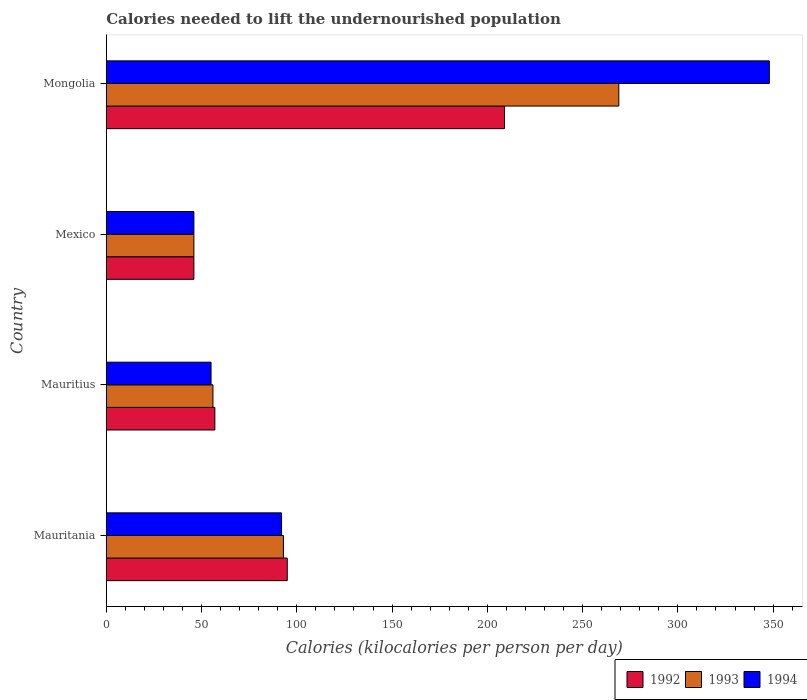Are the number of bars on each tick of the Y-axis equal?
Ensure brevity in your answer.  Yes. How many bars are there on the 2nd tick from the bottom?
Make the answer very short. 3. What is the label of the 3rd group of bars from the top?
Offer a very short reply. Mauritius. What is the total calories needed to lift the undernourished population in 1994 in Mexico?
Your response must be concise. 46. Across all countries, what is the maximum total calories needed to lift the undernourished population in 1993?
Your answer should be very brief. 269. In which country was the total calories needed to lift the undernourished population in 1992 maximum?
Your answer should be very brief. Mongolia. In which country was the total calories needed to lift the undernourished population in 1993 minimum?
Ensure brevity in your answer.  Mexico. What is the total total calories needed to lift the undernourished population in 1992 in the graph?
Offer a very short reply. 407. What is the difference between the total calories needed to lift the undernourished population in 1993 in Mexico and that in Mongolia?
Provide a short and direct response. -223. What is the difference between the total calories needed to lift the undernourished population in 1994 in Mauritius and the total calories needed to lift the undernourished population in 1992 in Mexico?
Keep it short and to the point. 9. What is the average total calories needed to lift the undernourished population in 1992 per country?
Provide a succinct answer. 101.75. What is the difference between the total calories needed to lift the undernourished population in 1992 and total calories needed to lift the undernourished population in 1994 in Mongolia?
Your response must be concise. -139. In how many countries, is the total calories needed to lift the undernourished population in 1994 greater than 100 kilocalories?
Your answer should be very brief. 1. What is the ratio of the total calories needed to lift the undernourished population in 1992 in Mexico to that in Mongolia?
Give a very brief answer. 0.22. What is the difference between the highest and the second highest total calories needed to lift the undernourished population in 1993?
Your answer should be compact. 176. What is the difference between the highest and the lowest total calories needed to lift the undernourished population in 1994?
Provide a succinct answer. 302. In how many countries, is the total calories needed to lift the undernourished population in 1993 greater than the average total calories needed to lift the undernourished population in 1993 taken over all countries?
Provide a short and direct response. 1. What does the 3rd bar from the top in Mauritius represents?
Offer a very short reply. 1992. How many bars are there?
Keep it short and to the point. 12. Are all the bars in the graph horizontal?
Offer a terse response. Yes. How many countries are there in the graph?
Offer a very short reply. 4. What is the difference between two consecutive major ticks on the X-axis?
Provide a succinct answer. 50. Are the values on the major ticks of X-axis written in scientific E-notation?
Offer a terse response. No. Does the graph contain any zero values?
Offer a very short reply. No. Does the graph contain grids?
Your response must be concise. No. Where does the legend appear in the graph?
Make the answer very short. Bottom right. How many legend labels are there?
Your response must be concise. 3. How are the legend labels stacked?
Your response must be concise. Horizontal. What is the title of the graph?
Your answer should be very brief. Calories needed to lift the undernourished population. Does "1980" appear as one of the legend labels in the graph?
Offer a terse response. No. What is the label or title of the X-axis?
Provide a short and direct response. Calories (kilocalories per person per day). What is the label or title of the Y-axis?
Make the answer very short. Country. What is the Calories (kilocalories per person per day) in 1993 in Mauritania?
Keep it short and to the point. 93. What is the Calories (kilocalories per person per day) in 1994 in Mauritania?
Give a very brief answer. 92. What is the Calories (kilocalories per person per day) of 1994 in Mauritius?
Your response must be concise. 55. What is the Calories (kilocalories per person per day) of 1992 in Mexico?
Provide a short and direct response. 46. What is the Calories (kilocalories per person per day) in 1993 in Mexico?
Your response must be concise. 46. What is the Calories (kilocalories per person per day) in 1994 in Mexico?
Give a very brief answer. 46. What is the Calories (kilocalories per person per day) in 1992 in Mongolia?
Your answer should be very brief. 209. What is the Calories (kilocalories per person per day) in 1993 in Mongolia?
Provide a short and direct response. 269. What is the Calories (kilocalories per person per day) of 1994 in Mongolia?
Provide a succinct answer. 348. Across all countries, what is the maximum Calories (kilocalories per person per day) of 1992?
Your answer should be compact. 209. Across all countries, what is the maximum Calories (kilocalories per person per day) of 1993?
Provide a succinct answer. 269. Across all countries, what is the maximum Calories (kilocalories per person per day) in 1994?
Your answer should be compact. 348. Across all countries, what is the minimum Calories (kilocalories per person per day) of 1992?
Offer a terse response. 46. Across all countries, what is the minimum Calories (kilocalories per person per day) of 1994?
Offer a very short reply. 46. What is the total Calories (kilocalories per person per day) in 1992 in the graph?
Give a very brief answer. 407. What is the total Calories (kilocalories per person per day) in 1993 in the graph?
Ensure brevity in your answer.  464. What is the total Calories (kilocalories per person per day) in 1994 in the graph?
Make the answer very short. 541. What is the difference between the Calories (kilocalories per person per day) of 1992 in Mauritania and that in Mauritius?
Your answer should be very brief. 38. What is the difference between the Calories (kilocalories per person per day) in 1994 in Mauritania and that in Mauritius?
Your answer should be compact. 37. What is the difference between the Calories (kilocalories per person per day) of 1992 in Mauritania and that in Mexico?
Your response must be concise. 49. What is the difference between the Calories (kilocalories per person per day) of 1993 in Mauritania and that in Mexico?
Your answer should be compact. 47. What is the difference between the Calories (kilocalories per person per day) in 1994 in Mauritania and that in Mexico?
Keep it short and to the point. 46. What is the difference between the Calories (kilocalories per person per day) in 1992 in Mauritania and that in Mongolia?
Ensure brevity in your answer.  -114. What is the difference between the Calories (kilocalories per person per day) in 1993 in Mauritania and that in Mongolia?
Offer a terse response. -176. What is the difference between the Calories (kilocalories per person per day) in 1994 in Mauritania and that in Mongolia?
Keep it short and to the point. -256. What is the difference between the Calories (kilocalories per person per day) of 1993 in Mauritius and that in Mexico?
Your answer should be very brief. 10. What is the difference between the Calories (kilocalories per person per day) in 1992 in Mauritius and that in Mongolia?
Your answer should be very brief. -152. What is the difference between the Calories (kilocalories per person per day) in 1993 in Mauritius and that in Mongolia?
Your answer should be very brief. -213. What is the difference between the Calories (kilocalories per person per day) in 1994 in Mauritius and that in Mongolia?
Ensure brevity in your answer.  -293. What is the difference between the Calories (kilocalories per person per day) in 1992 in Mexico and that in Mongolia?
Your answer should be compact. -163. What is the difference between the Calories (kilocalories per person per day) in 1993 in Mexico and that in Mongolia?
Make the answer very short. -223. What is the difference between the Calories (kilocalories per person per day) of 1994 in Mexico and that in Mongolia?
Ensure brevity in your answer.  -302. What is the difference between the Calories (kilocalories per person per day) of 1992 in Mauritania and the Calories (kilocalories per person per day) of 1994 in Mauritius?
Your response must be concise. 40. What is the difference between the Calories (kilocalories per person per day) in 1992 in Mauritania and the Calories (kilocalories per person per day) in 1993 in Mexico?
Make the answer very short. 49. What is the difference between the Calories (kilocalories per person per day) of 1992 in Mauritania and the Calories (kilocalories per person per day) of 1993 in Mongolia?
Your response must be concise. -174. What is the difference between the Calories (kilocalories per person per day) in 1992 in Mauritania and the Calories (kilocalories per person per day) in 1994 in Mongolia?
Provide a succinct answer. -253. What is the difference between the Calories (kilocalories per person per day) in 1993 in Mauritania and the Calories (kilocalories per person per day) in 1994 in Mongolia?
Make the answer very short. -255. What is the difference between the Calories (kilocalories per person per day) in 1992 in Mauritius and the Calories (kilocalories per person per day) in 1993 in Mexico?
Your answer should be very brief. 11. What is the difference between the Calories (kilocalories per person per day) of 1992 in Mauritius and the Calories (kilocalories per person per day) of 1994 in Mexico?
Ensure brevity in your answer.  11. What is the difference between the Calories (kilocalories per person per day) in 1993 in Mauritius and the Calories (kilocalories per person per day) in 1994 in Mexico?
Provide a short and direct response. 10. What is the difference between the Calories (kilocalories per person per day) of 1992 in Mauritius and the Calories (kilocalories per person per day) of 1993 in Mongolia?
Provide a short and direct response. -212. What is the difference between the Calories (kilocalories per person per day) in 1992 in Mauritius and the Calories (kilocalories per person per day) in 1994 in Mongolia?
Your response must be concise. -291. What is the difference between the Calories (kilocalories per person per day) in 1993 in Mauritius and the Calories (kilocalories per person per day) in 1994 in Mongolia?
Your response must be concise. -292. What is the difference between the Calories (kilocalories per person per day) in 1992 in Mexico and the Calories (kilocalories per person per day) in 1993 in Mongolia?
Give a very brief answer. -223. What is the difference between the Calories (kilocalories per person per day) of 1992 in Mexico and the Calories (kilocalories per person per day) of 1994 in Mongolia?
Provide a succinct answer. -302. What is the difference between the Calories (kilocalories per person per day) of 1993 in Mexico and the Calories (kilocalories per person per day) of 1994 in Mongolia?
Provide a succinct answer. -302. What is the average Calories (kilocalories per person per day) in 1992 per country?
Offer a very short reply. 101.75. What is the average Calories (kilocalories per person per day) in 1993 per country?
Offer a very short reply. 116. What is the average Calories (kilocalories per person per day) in 1994 per country?
Provide a short and direct response. 135.25. What is the difference between the Calories (kilocalories per person per day) in 1992 and Calories (kilocalories per person per day) in 1993 in Mauritius?
Your answer should be compact. 1. What is the difference between the Calories (kilocalories per person per day) of 1992 and Calories (kilocalories per person per day) of 1993 in Mexico?
Your answer should be compact. 0. What is the difference between the Calories (kilocalories per person per day) of 1992 and Calories (kilocalories per person per day) of 1993 in Mongolia?
Provide a short and direct response. -60. What is the difference between the Calories (kilocalories per person per day) of 1992 and Calories (kilocalories per person per day) of 1994 in Mongolia?
Your response must be concise. -139. What is the difference between the Calories (kilocalories per person per day) in 1993 and Calories (kilocalories per person per day) in 1994 in Mongolia?
Ensure brevity in your answer.  -79. What is the ratio of the Calories (kilocalories per person per day) of 1992 in Mauritania to that in Mauritius?
Offer a very short reply. 1.67. What is the ratio of the Calories (kilocalories per person per day) in 1993 in Mauritania to that in Mauritius?
Keep it short and to the point. 1.66. What is the ratio of the Calories (kilocalories per person per day) in 1994 in Mauritania to that in Mauritius?
Your response must be concise. 1.67. What is the ratio of the Calories (kilocalories per person per day) of 1992 in Mauritania to that in Mexico?
Your response must be concise. 2.07. What is the ratio of the Calories (kilocalories per person per day) of 1993 in Mauritania to that in Mexico?
Your response must be concise. 2.02. What is the ratio of the Calories (kilocalories per person per day) of 1992 in Mauritania to that in Mongolia?
Your answer should be very brief. 0.45. What is the ratio of the Calories (kilocalories per person per day) of 1993 in Mauritania to that in Mongolia?
Your response must be concise. 0.35. What is the ratio of the Calories (kilocalories per person per day) in 1994 in Mauritania to that in Mongolia?
Give a very brief answer. 0.26. What is the ratio of the Calories (kilocalories per person per day) of 1992 in Mauritius to that in Mexico?
Provide a short and direct response. 1.24. What is the ratio of the Calories (kilocalories per person per day) of 1993 in Mauritius to that in Mexico?
Offer a terse response. 1.22. What is the ratio of the Calories (kilocalories per person per day) of 1994 in Mauritius to that in Mexico?
Give a very brief answer. 1.2. What is the ratio of the Calories (kilocalories per person per day) of 1992 in Mauritius to that in Mongolia?
Your response must be concise. 0.27. What is the ratio of the Calories (kilocalories per person per day) of 1993 in Mauritius to that in Mongolia?
Your answer should be compact. 0.21. What is the ratio of the Calories (kilocalories per person per day) of 1994 in Mauritius to that in Mongolia?
Provide a short and direct response. 0.16. What is the ratio of the Calories (kilocalories per person per day) of 1992 in Mexico to that in Mongolia?
Offer a terse response. 0.22. What is the ratio of the Calories (kilocalories per person per day) of 1993 in Mexico to that in Mongolia?
Your answer should be compact. 0.17. What is the ratio of the Calories (kilocalories per person per day) in 1994 in Mexico to that in Mongolia?
Your response must be concise. 0.13. What is the difference between the highest and the second highest Calories (kilocalories per person per day) in 1992?
Provide a short and direct response. 114. What is the difference between the highest and the second highest Calories (kilocalories per person per day) in 1993?
Provide a succinct answer. 176. What is the difference between the highest and the second highest Calories (kilocalories per person per day) in 1994?
Offer a very short reply. 256. What is the difference between the highest and the lowest Calories (kilocalories per person per day) in 1992?
Your answer should be very brief. 163. What is the difference between the highest and the lowest Calories (kilocalories per person per day) in 1993?
Give a very brief answer. 223. What is the difference between the highest and the lowest Calories (kilocalories per person per day) of 1994?
Keep it short and to the point. 302. 